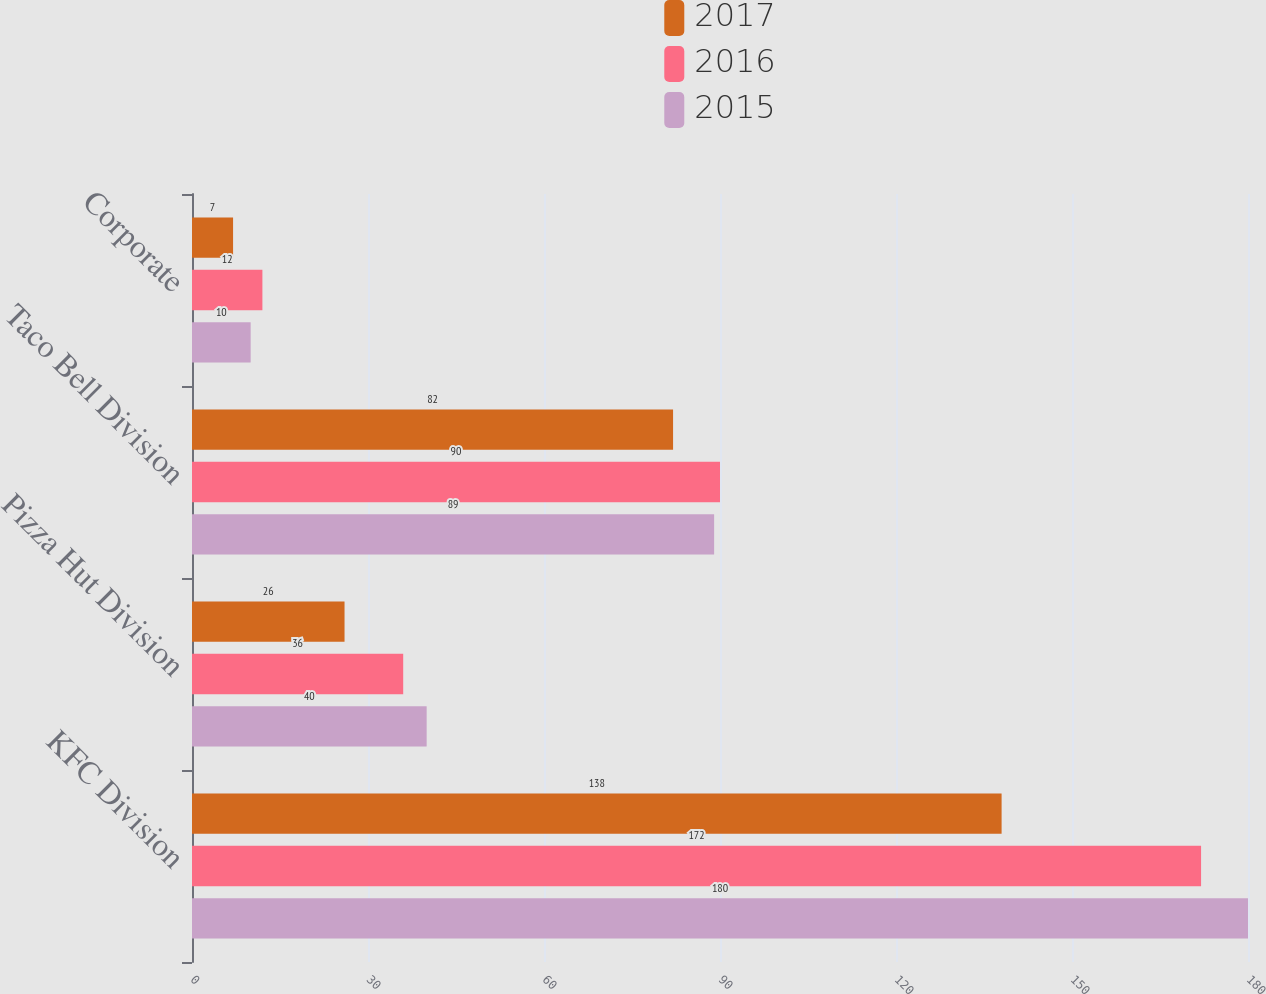Convert chart. <chart><loc_0><loc_0><loc_500><loc_500><stacked_bar_chart><ecel><fcel>KFC Division<fcel>Pizza Hut Division<fcel>Taco Bell Division<fcel>Corporate<nl><fcel>2017<fcel>138<fcel>26<fcel>82<fcel>7<nl><fcel>2016<fcel>172<fcel>36<fcel>90<fcel>12<nl><fcel>2015<fcel>180<fcel>40<fcel>89<fcel>10<nl></chart> 